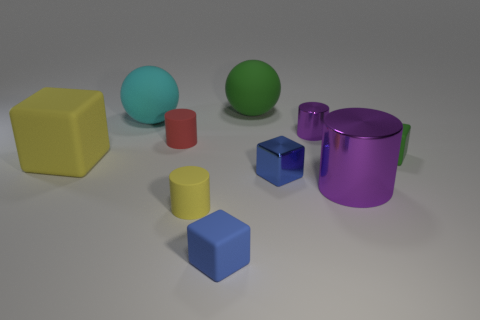Subtract all large matte cubes. How many cubes are left? 3 Subtract all cubes. How many objects are left? 6 Subtract 4 blocks. How many blocks are left? 0 Subtract all green cylinders. How many green cubes are left? 1 Subtract all big cyan matte things. Subtract all small shiny objects. How many objects are left? 7 Add 4 purple objects. How many purple objects are left? 6 Add 8 tiny purple objects. How many tiny purple objects exist? 9 Subtract all yellow cylinders. How many cylinders are left? 3 Subtract 0 brown blocks. How many objects are left? 10 Subtract all cyan balls. Subtract all gray cylinders. How many balls are left? 1 